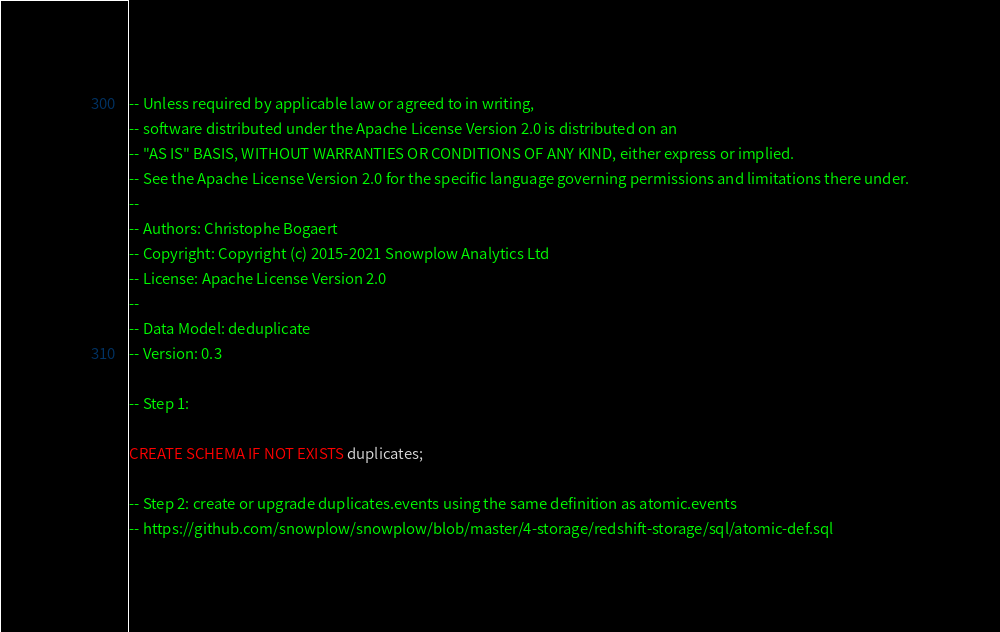<code> <loc_0><loc_0><loc_500><loc_500><_SQL_>-- Unless required by applicable law or agreed to in writing,
-- software distributed under the Apache License Version 2.0 is distributed on an
-- "AS IS" BASIS, WITHOUT WARRANTIES OR CONDITIONS OF ANY KIND, either express or implied.
-- See the Apache License Version 2.0 for the specific language governing permissions and limitations there under.
--
-- Authors: Christophe Bogaert
-- Copyright: Copyright (c) 2015-2021 Snowplow Analytics Ltd
-- License: Apache License Version 2.0
--
-- Data Model: deduplicate
-- Version: 0.3

-- Step 1:

CREATE SCHEMA IF NOT EXISTS duplicates;

-- Step 2: create or upgrade duplicates.events using the same definition as atomic.events
-- https://github.com/snowplow/snowplow/blob/master/4-storage/redshift-storage/sql/atomic-def.sql
</code> 